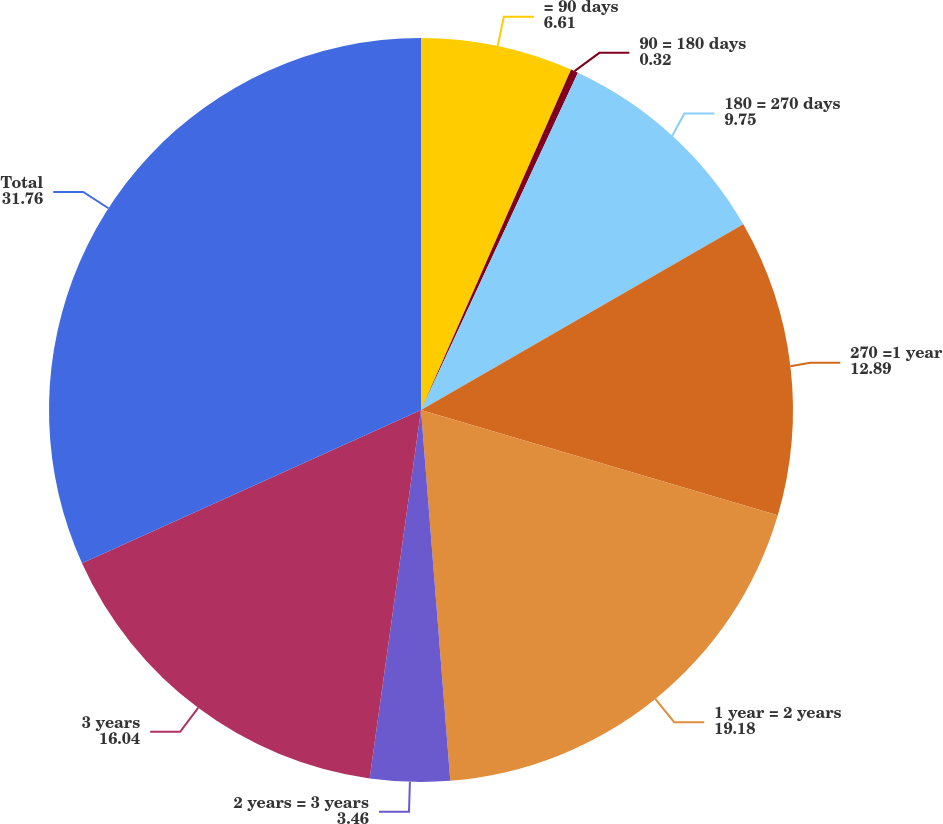<chart> <loc_0><loc_0><loc_500><loc_500><pie_chart><fcel>= 90 days<fcel>90 = 180 days<fcel>180 = 270 days<fcel>270 =1 year<fcel>1 year = 2 years<fcel>2 years = 3 years<fcel>3 years<fcel>Total<nl><fcel>6.61%<fcel>0.32%<fcel>9.75%<fcel>12.89%<fcel>19.18%<fcel>3.46%<fcel>16.04%<fcel>31.76%<nl></chart> 